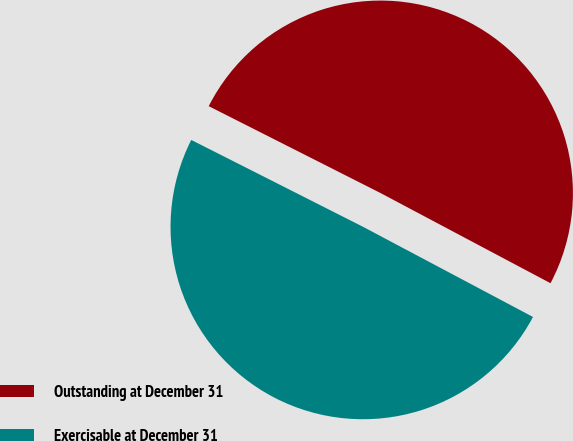Convert chart to OTSL. <chart><loc_0><loc_0><loc_500><loc_500><pie_chart><fcel>Outstanding at December 31<fcel>Exercisable at December 31<nl><fcel>50.31%<fcel>49.69%<nl></chart> 